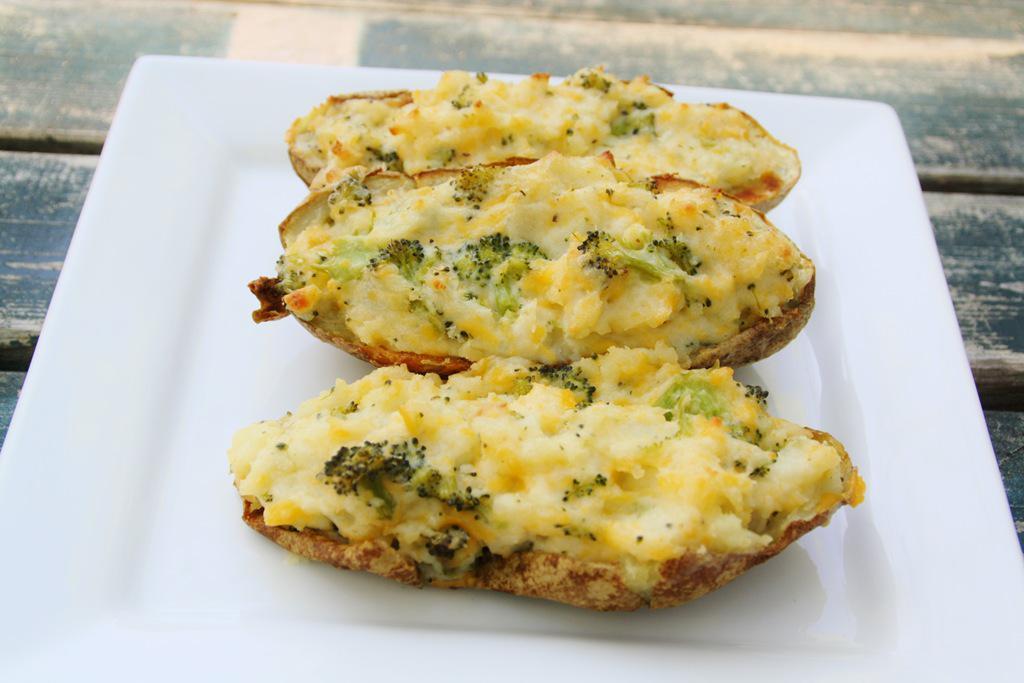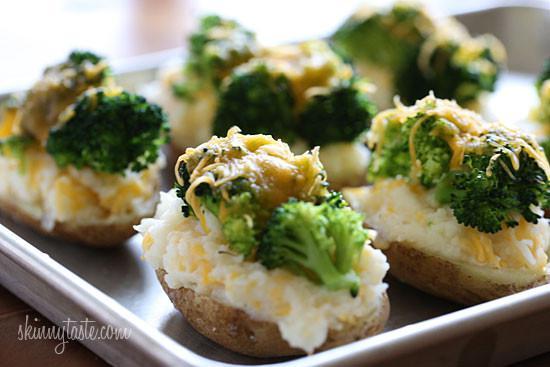The first image is the image on the left, the second image is the image on the right. Assess this claim about the two images: "There is one piece of food on the dish on the right.". Correct or not? Answer yes or no. No. The first image is the image on the left, the second image is the image on the right. Analyze the images presented: Is the assertion "Each image contains at least three baked stuffed potato." valid? Answer yes or no. Yes. 